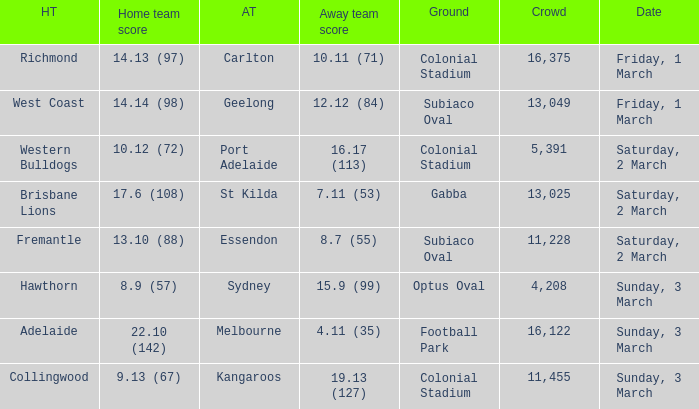Who is the guest team when the home team manages to score 17.6 (108)? St Kilda. 